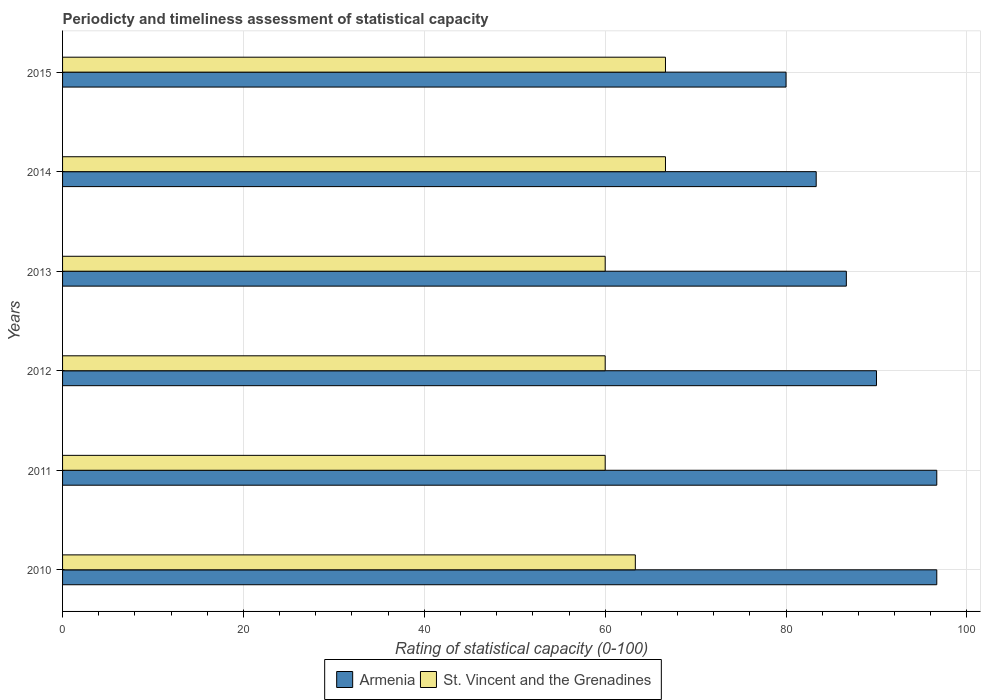Are the number of bars per tick equal to the number of legend labels?
Your answer should be compact. Yes. How many bars are there on the 6th tick from the bottom?
Provide a succinct answer. 2. What is the label of the 6th group of bars from the top?
Provide a succinct answer. 2010. In how many cases, is the number of bars for a given year not equal to the number of legend labels?
Your answer should be compact. 0. What is the rating of statistical capacity in Armenia in 2010?
Your answer should be very brief. 96.67. Across all years, what is the maximum rating of statistical capacity in Armenia?
Provide a succinct answer. 96.67. Across all years, what is the minimum rating of statistical capacity in St. Vincent and the Grenadines?
Give a very brief answer. 60. In which year was the rating of statistical capacity in St. Vincent and the Grenadines maximum?
Keep it short and to the point. 2015. What is the total rating of statistical capacity in Armenia in the graph?
Make the answer very short. 533.33. What is the difference between the rating of statistical capacity in Armenia in 2013 and that in 2014?
Offer a very short reply. 3.33. What is the difference between the rating of statistical capacity in St. Vincent and the Grenadines in 2011 and the rating of statistical capacity in Armenia in 2014?
Give a very brief answer. -23.33. What is the average rating of statistical capacity in St. Vincent and the Grenadines per year?
Provide a short and direct response. 62.78. In the year 2014, what is the difference between the rating of statistical capacity in Armenia and rating of statistical capacity in St. Vincent and the Grenadines?
Your answer should be compact. 16.67. What is the ratio of the rating of statistical capacity in St. Vincent and the Grenadines in 2014 to that in 2015?
Offer a very short reply. 1. Is the rating of statistical capacity in St. Vincent and the Grenadines in 2014 less than that in 2015?
Ensure brevity in your answer.  Yes. What is the difference between the highest and the lowest rating of statistical capacity in St. Vincent and the Grenadines?
Your answer should be very brief. 6.67. Is the sum of the rating of statistical capacity in Armenia in 2010 and 2011 greater than the maximum rating of statistical capacity in St. Vincent and the Grenadines across all years?
Make the answer very short. Yes. What does the 2nd bar from the top in 2012 represents?
Provide a short and direct response. Armenia. What does the 2nd bar from the bottom in 2015 represents?
Keep it short and to the point. St. Vincent and the Grenadines. What is the difference between two consecutive major ticks on the X-axis?
Keep it short and to the point. 20. Are the values on the major ticks of X-axis written in scientific E-notation?
Your response must be concise. No. Does the graph contain any zero values?
Ensure brevity in your answer.  No. Does the graph contain grids?
Give a very brief answer. Yes. How many legend labels are there?
Provide a short and direct response. 2. What is the title of the graph?
Give a very brief answer. Periodicty and timeliness assessment of statistical capacity. What is the label or title of the X-axis?
Keep it short and to the point. Rating of statistical capacity (0-100). What is the label or title of the Y-axis?
Your answer should be compact. Years. What is the Rating of statistical capacity (0-100) of Armenia in 2010?
Ensure brevity in your answer.  96.67. What is the Rating of statistical capacity (0-100) in St. Vincent and the Grenadines in 2010?
Offer a terse response. 63.33. What is the Rating of statistical capacity (0-100) in Armenia in 2011?
Your answer should be very brief. 96.67. What is the Rating of statistical capacity (0-100) of St. Vincent and the Grenadines in 2012?
Your answer should be very brief. 60. What is the Rating of statistical capacity (0-100) of Armenia in 2013?
Your response must be concise. 86.67. What is the Rating of statistical capacity (0-100) in Armenia in 2014?
Offer a very short reply. 83.33. What is the Rating of statistical capacity (0-100) of St. Vincent and the Grenadines in 2014?
Offer a terse response. 66.67. What is the Rating of statistical capacity (0-100) of Armenia in 2015?
Make the answer very short. 80. What is the Rating of statistical capacity (0-100) of St. Vincent and the Grenadines in 2015?
Make the answer very short. 66.67. Across all years, what is the maximum Rating of statistical capacity (0-100) of Armenia?
Give a very brief answer. 96.67. Across all years, what is the maximum Rating of statistical capacity (0-100) in St. Vincent and the Grenadines?
Ensure brevity in your answer.  66.67. Across all years, what is the minimum Rating of statistical capacity (0-100) of Armenia?
Provide a short and direct response. 80. What is the total Rating of statistical capacity (0-100) of Armenia in the graph?
Make the answer very short. 533.33. What is the total Rating of statistical capacity (0-100) of St. Vincent and the Grenadines in the graph?
Your answer should be compact. 376.67. What is the difference between the Rating of statistical capacity (0-100) of St. Vincent and the Grenadines in 2010 and that in 2011?
Keep it short and to the point. 3.33. What is the difference between the Rating of statistical capacity (0-100) in Armenia in 2010 and that in 2012?
Give a very brief answer. 6.67. What is the difference between the Rating of statistical capacity (0-100) in Armenia in 2010 and that in 2014?
Your answer should be compact. 13.33. What is the difference between the Rating of statistical capacity (0-100) of St. Vincent and the Grenadines in 2010 and that in 2014?
Ensure brevity in your answer.  -3.33. What is the difference between the Rating of statistical capacity (0-100) of Armenia in 2010 and that in 2015?
Your response must be concise. 16.67. What is the difference between the Rating of statistical capacity (0-100) in St. Vincent and the Grenadines in 2010 and that in 2015?
Your answer should be compact. -3.33. What is the difference between the Rating of statistical capacity (0-100) of St. Vincent and the Grenadines in 2011 and that in 2013?
Keep it short and to the point. 0. What is the difference between the Rating of statistical capacity (0-100) of Armenia in 2011 and that in 2014?
Give a very brief answer. 13.33. What is the difference between the Rating of statistical capacity (0-100) in St. Vincent and the Grenadines in 2011 and that in 2014?
Your answer should be very brief. -6.67. What is the difference between the Rating of statistical capacity (0-100) in Armenia in 2011 and that in 2015?
Your response must be concise. 16.67. What is the difference between the Rating of statistical capacity (0-100) of St. Vincent and the Grenadines in 2011 and that in 2015?
Offer a very short reply. -6.67. What is the difference between the Rating of statistical capacity (0-100) in Armenia in 2012 and that in 2013?
Your response must be concise. 3.33. What is the difference between the Rating of statistical capacity (0-100) of Armenia in 2012 and that in 2014?
Your answer should be compact. 6.67. What is the difference between the Rating of statistical capacity (0-100) in St. Vincent and the Grenadines in 2012 and that in 2014?
Your answer should be very brief. -6.67. What is the difference between the Rating of statistical capacity (0-100) of St. Vincent and the Grenadines in 2012 and that in 2015?
Give a very brief answer. -6.67. What is the difference between the Rating of statistical capacity (0-100) in St. Vincent and the Grenadines in 2013 and that in 2014?
Keep it short and to the point. -6.67. What is the difference between the Rating of statistical capacity (0-100) in Armenia in 2013 and that in 2015?
Provide a succinct answer. 6.67. What is the difference between the Rating of statistical capacity (0-100) in St. Vincent and the Grenadines in 2013 and that in 2015?
Your answer should be very brief. -6.67. What is the difference between the Rating of statistical capacity (0-100) of St. Vincent and the Grenadines in 2014 and that in 2015?
Your answer should be very brief. -0. What is the difference between the Rating of statistical capacity (0-100) in Armenia in 2010 and the Rating of statistical capacity (0-100) in St. Vincent and the Grenadines in 2011?
Provide a short and direct response. 36.67. What is the difference between the Rating of statistical capacity (0-100) of Armenia in 2010 and the Rating of statistical capacity (0-100) of St. Vincent and the Grenadines in 2012?
Give a very brief answer. 36.67. What is the difference between the Rating of statistical capacity (0-100) of Armenia in 2010 and the Rating of statistical capacity (0-100) of St. Vincent and the Grenadines in 2013?
Your answer should be very brief. 36.67. What is the difference between the Rating of statistical capacity (0-100) in Armenia in 2010 and the Rating of statistical capacity (0-100) in St. Vincent and the Grenadines in 2014?
Give a very brief answer. 30. What is the difference between the Rating of statistical capacity (0-100) of Armenia in 2010 and the Rating of statistical capacity (0-100) of St. Vincent and the Grenadines in 2015?
Offer a terse response. 30. What is the difference between the Rating of statistical capacity (0-100) of Armenia in 2011 and the Rating of statistical capacity (0-100) of St. Vincent and the Grenadines in 2012?
Provide a succinct answer. 36.67. What is the difference between the Rating of statistical capacity (0-100) of Armenia in 2011 and the Rating of statistical capacity (0-100) of St. Vincent and the Grenadines in 2013?
Give a very brief answer. 36.67. What is the difference between the Rating of statistical capacity (0-100) in Armenia in 2012 and the Rating of statistical capacity (0-100) in St. Vincent and the Grenadines in 2014?
Ensure brevity in your answer.  23.33. What is the difference between the Rating of statistical capacity (0-100) of Armenia in 2012 and the Rating of statistical capacity (0-100) of St. Vincent and the Grenadines in 2015?
Give a very brief answer. 23.33. What is the difference between the Rating of statistical capacity (0-100) in Armenia in 2013 and the Rating of statistical capacity (0-100) in St. Vincent and the Grenadines in 2015?
Give a very brief answer. 20. What is the difference between the Rating of statistical capacity (0-100) in Armenia in 2014 and the Rating of statistical capacity (0-100) in St. Vincent and the Grenadines in 2015?
Provide a short and direct response. 16.67. What is the average Rating of statistical capacity (0-100) in Armenia per year?
Offer a very short reply. 88.89. What is the average Rating of statistical capacity (0-100) in St. Vincent and the Grenadines per year?
Give a very brief answer. 62.78. In the year 2010, what is the difference between the Rating of statistical capacity (0-100) of Armenia and Rating of statistical capacity (0-100) of St. Vincent and the Grenadines?
Your answer should be very brief. 33.33. In the year 2011, what is the difference between the Rating of statistical capacity (0-100) of Armenia and Rating of statistical capacity (0-100) of St. Vincent and the Grenadines?
Offer a terse response. 36.67. In the year 2012, what is the difference between the Rating of statistical capacity (0-100) in Armenia and Rating of statistical capacity (0-100) in St. Vincent and the Grenadines?
Your response must be concise. 30. In the year 2013, what is the difference between the Rating of statistical capacity (0-100) of Armenia and Rating of statistical capacity (0-100) of St. Vincent and the Grenadines?
Offer a terse response. 26.67. In the year 2014, what is the difference between the Rating of statistical capacity (0-100) in Armenia and Rating of statistical capacity (0-100) in St. Vincent and the Grenadines?
Provide a short and direct response. 16.67. In the year 2015, what is the difference between the Rating of statistical capacity (0-100) of Armenia and Rating of statistical capacity (0-100) of St. Vincent and the Grenadines?
Your answer should be compact. 13.33. What is the ratio of the Rating of statistical capacity (0-100) of Armenia in 2010 to that in 2011?
Offer a terse response. 1. What is the ratio of the Rating of statistical capacity (0-100) of St. Vincent and the Grenadines in 2010 to that in 2011?
Ensure brevity in your answer.  1.06. What is the ratio of the Rating of statistical capacity (0-100) in Armenia in 2010 to that in 2012?
Offer a terse response. 1.07. What is the ratio of the Rating of statistical capacity (0-100) of St. Vincent and the Grenadines in 2010 to that in 2012?
Ensure brevity in your answer.  1.06. What is the ratio of the Rating of statistical capacity (0-100) in Armenia in 2010 to that in 2013?
Make the answer very short. 1.12. What is the ratio of the Rating of statistical capacity (0-100) in St. Vincent and the Grenadines in 2010 to that in 2013?
Your answer should be very brief. 1.06. What is the ratio of the Rating of statistical capacity (0-100) in Armenia in 2010 to that in 2014?
Your answer should be compact. 1.16. What is the ratio of the Rating of statistical capacity (0-100) in St. Vincent and the Grenadines in 2010 to that in 2014?
Offer a terse response. 0.95. What is the ratio of the Rating of statistical capacity (0-100) of Armenia in 2010 to that in 2015?
Offer a very short reply. 1.21. What is the ratio of the Rating of statistical capacity (0-100) in St. Vincent and the Grenadines in 2010 to that in 2015?
Your answer should be very brief. 0.95. What is the ratio of the Rating of statistical capacity (0-100) of Armenia in 2011 to that in 2012?
Your response must be concise. 1.07. What is the ratio of the Rating of statistical capacity (0-100) of Armenia in 2011 to that in 2013?
Provide a succinct answer. 1.12. What is the ratio of the Rating of statistical capacity (0-100) in Armenia in 2011 to that in 2014?
Your response must be concise. 1.16. What is the ratio of the Rating of statistical capacity (0-100) of Armenia in 2011 to that in 2015?
Keep it short and to the point. 1.21. What is the ratio of the Rating of statistical capacity (0-100) of St. Vincent and the Grenadines in 2011 to that in 2015?
Give a very brief answer. 0.9. What is the ratio of the Rating of statistical capacity (0-100) of St. Vincent and the Grenadines in 2012 to that in 2014?
Your response must be concise. 0.9. What is the ratio of the Rating of statistical capacity (0-100) in St. Vincent and the Grenadines in 2012 to that in 2015?
Make the answer very short. 0.9. What is the ratio of the Rating of statistical capacity (0-100) in St. Vincent and the Grenadines in 2013 to that in 2014?
Your answer should be compact. 0.9. What is the ratio of the Rating of statistical capacity (0-100) of Armenia in 2014 to that in 2015?
Make the answer very short. 1.04. What is the difference between the highest and the second highest Rating of statistical capacity (0-100) of Armenia?
Make the answer very short. 0. What is the difference between the highest and the lowest Rating of statistical capacity (0-100) in Armenia?
Provide a short and direct response. 16.67. 